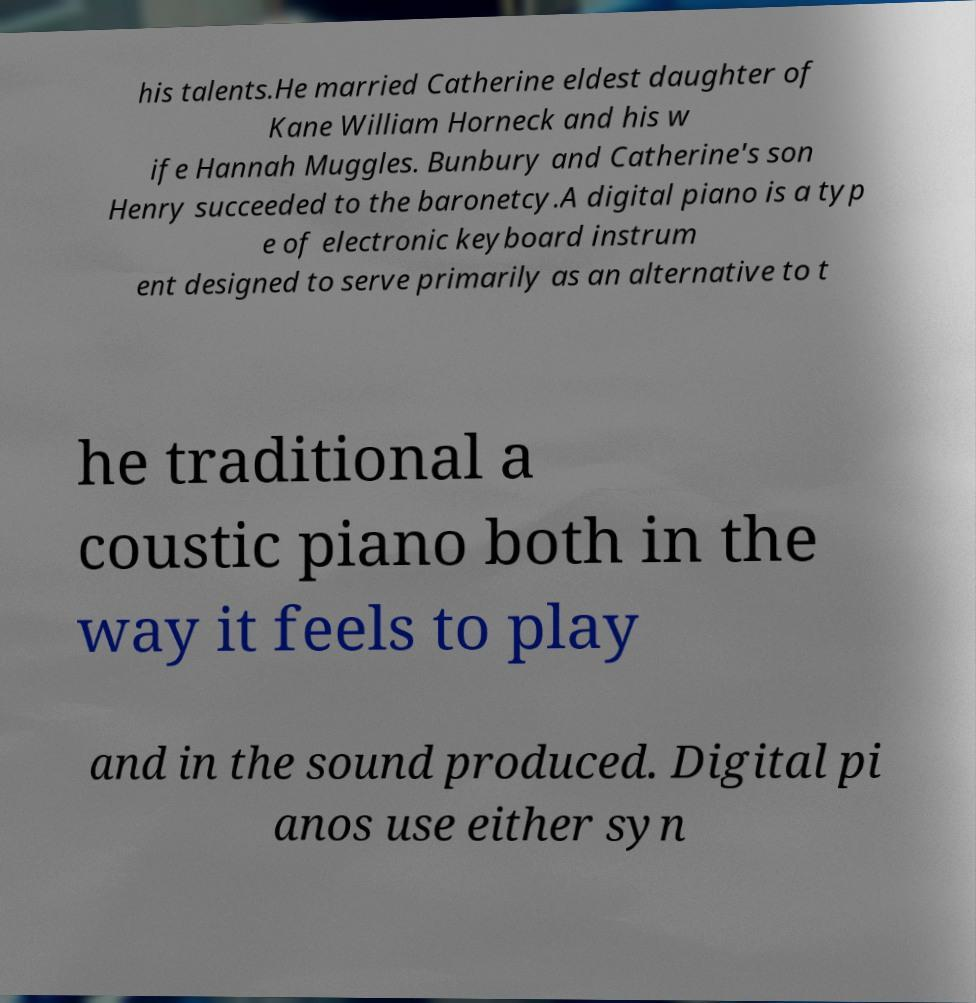Please read and relay the text visible in this image. What does it say? his talents.He married Catherine eldest daughter of Kane William Horneck and his w ife Hannah Muggles. Bunbury and Catherine's son Henry succeeded to the baronetcy.A digital piano is a typ e of electronic keyboard instrum ent designed to serve primarily as an alternative to t he traditional a coustic piano both in the way it feels to play and in the sound produced. Digital pi anos use either syn 